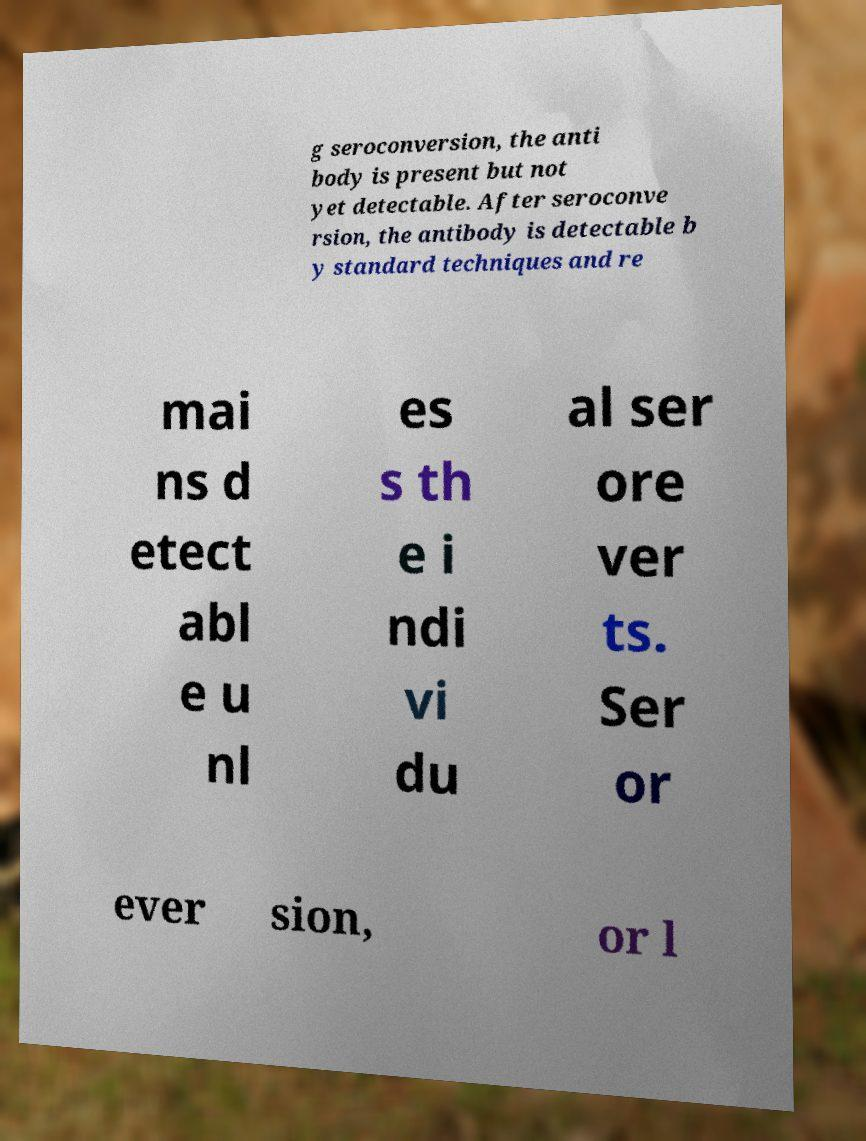Could you extract and type out the text from this image? g seroconversion, the anti body is present but not yet detectable. After seroconve rsion, the antibody is detectable b y standard techniques and re mai ns d etect abl e u nl es s th e i ndi vi du al ser ore ver ts. Ser or ever sion, or l 